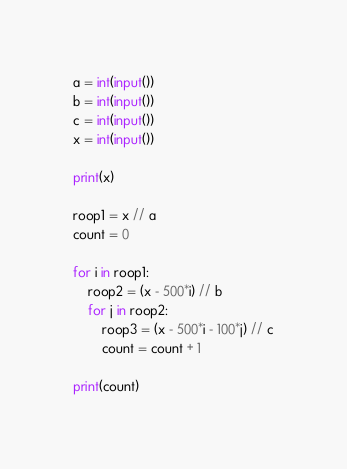Convert code to text. <code><loc_0><loc_0><loc_500><loc_500><_Python_>a = int(input())
b = int(input())
c = int(input())
x = int(input())

print(x)

roop1 = x // a
count = 0

for i in roop1:
    roop2 = (x - 500*i) // b
    for j in roop2:
        roop3 = (x - 500*i - 100*j) // c
        count = count + 1

print(count)</code> 